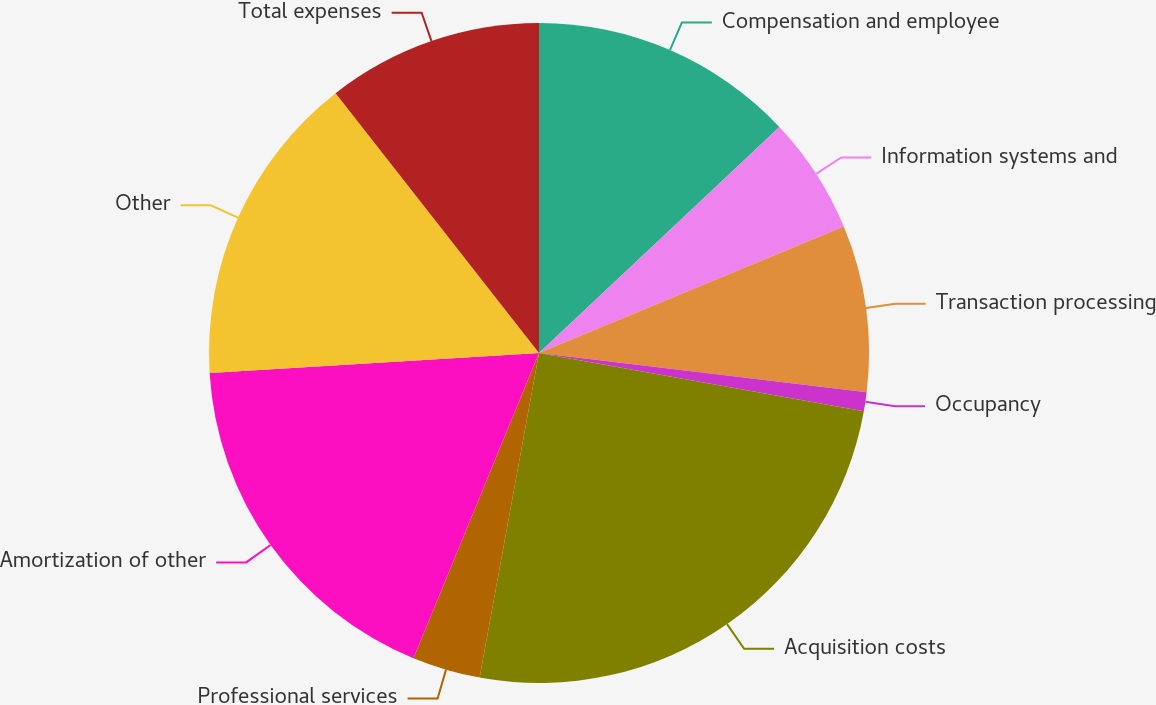<chart> <loc_0><loc_0><loc_500><loc_500><pie_chart><fcel>Compensation and employee<fcel>Information systems and<fcel>Transaction processing<fcel>Occupancy<fcel>Acquisition costs<fcel>Professional services<fcel>Amortization of other<fcel>Other<fcel>Total expenses<nl><fcel>12.99%<fcel>5.75%<fcel>8.16%<fcel>0.92%<fcel>25.06%<fcel>3.33%<fcel>17.82%<fcel>15.4%<fcel>10.57%<nl></chart> 